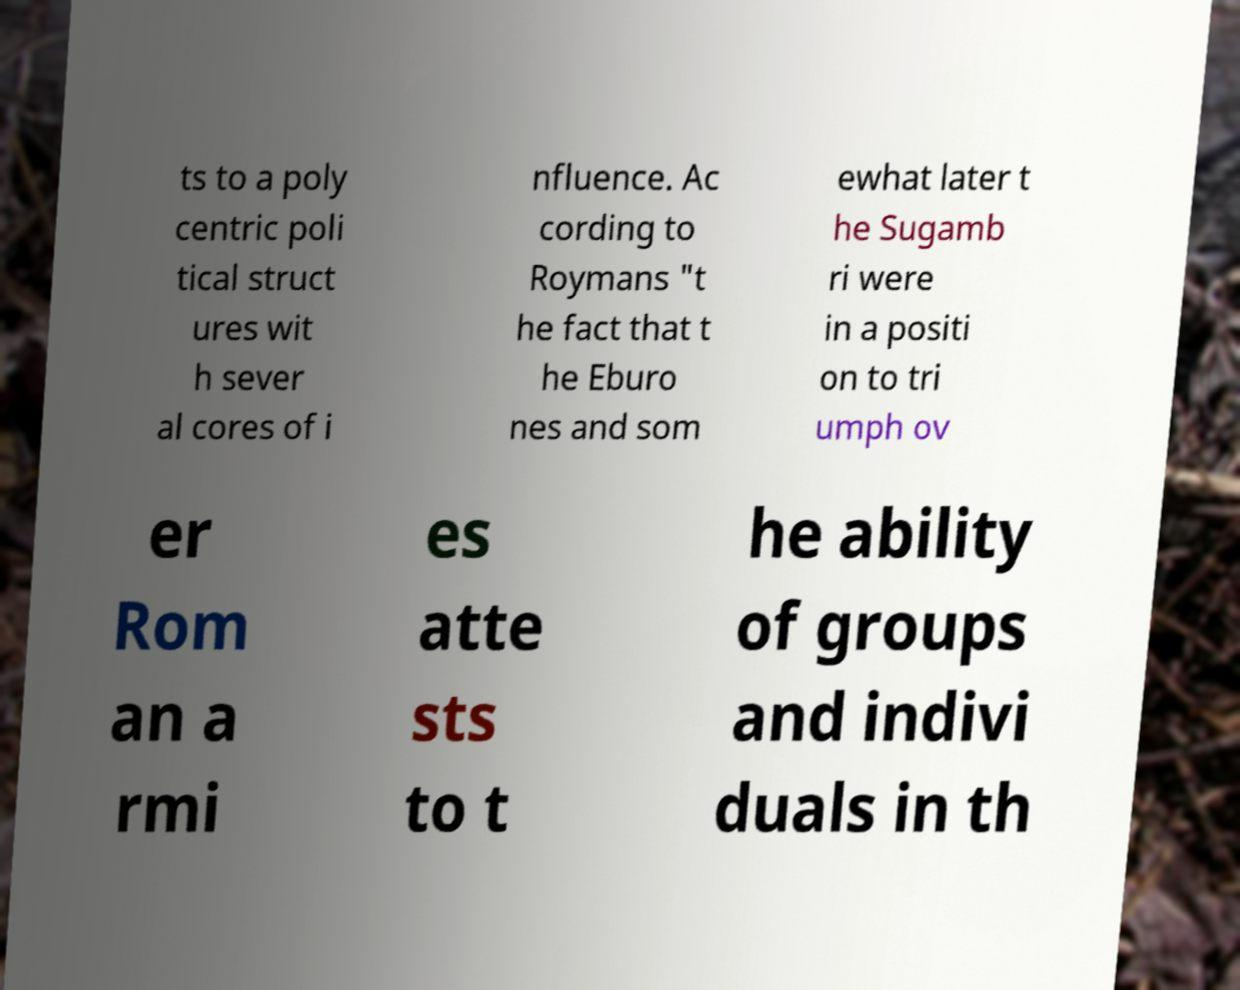Could you assist in decoding the text presented in this image and type it out clearly? ts to a poly centric poli tical struct ures wit h sever al cores of i nfluence. Ac cording to Roymans "t he fact that t he Eburo nes and som ewhat later t he Sugamb ri were in a positi on to tri umph ov er Rom an a rmi es atte sts to t he ability of groups and indivi duals in th 